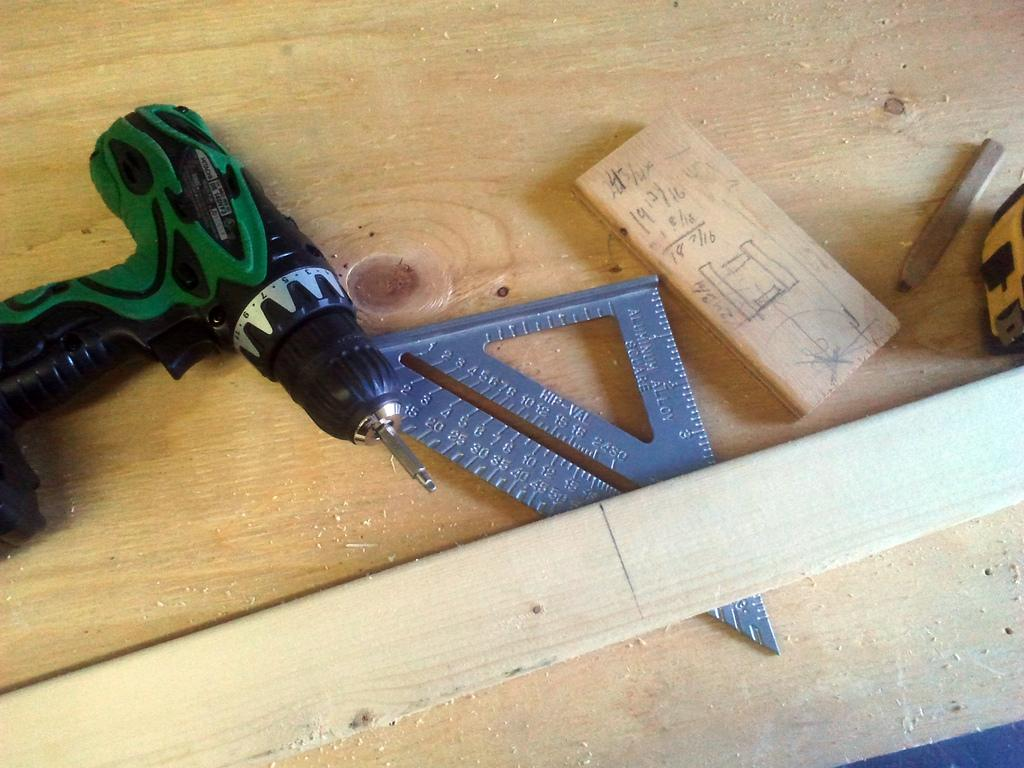<image>
Write a terse but informative summary of the picture. A woodworking project in progress with numbers written on a piece of wood, among them is 19 12/16. 